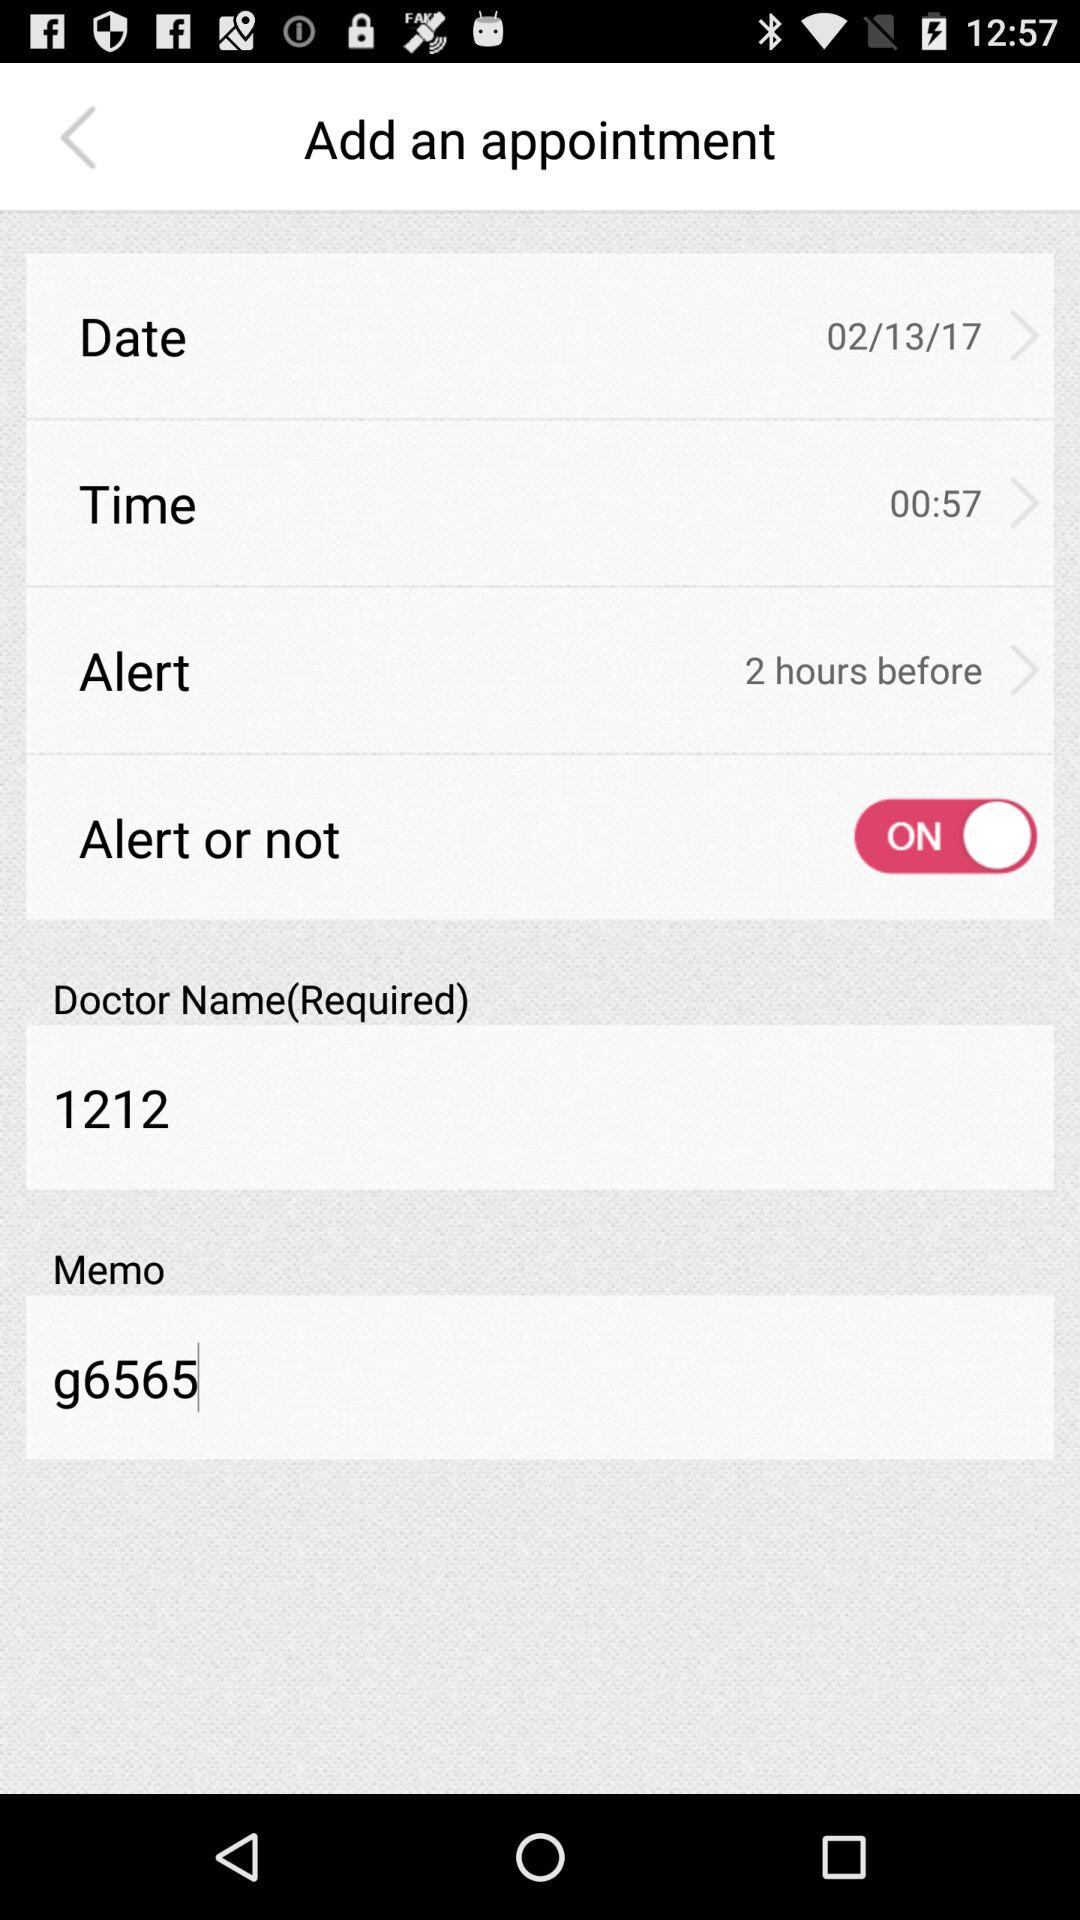How many hours ago was the alert selected? The alert was selected 2 hours before. 